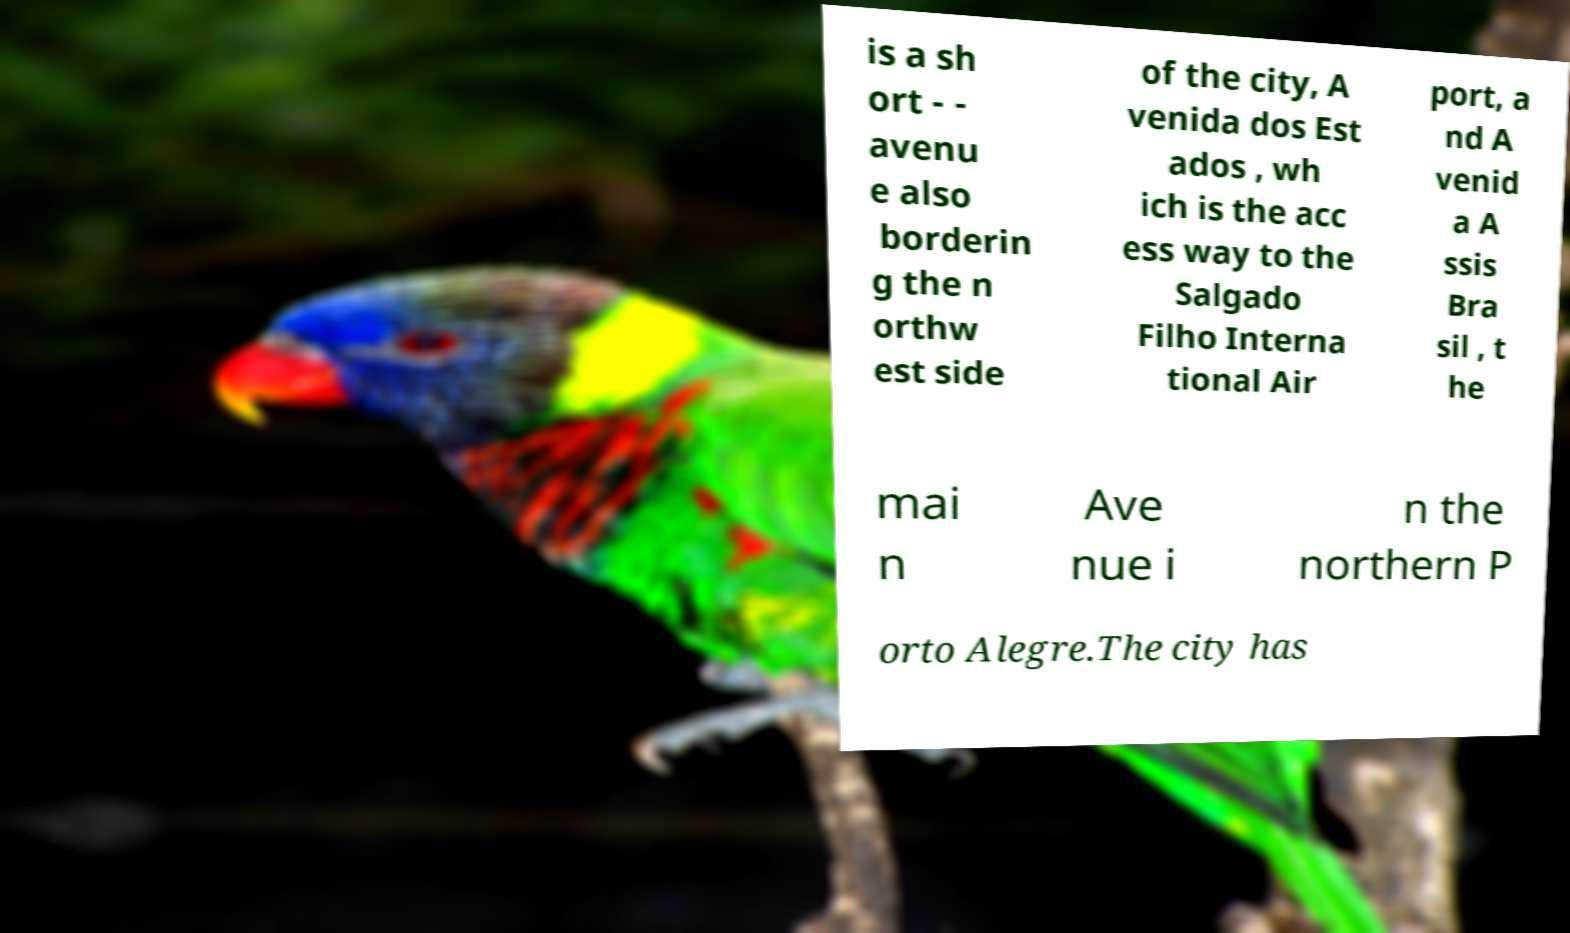Please read and relay the text visible in this image. What does it say? is a sh ort - - avenu e also borderin g the n orthw est side of the city, A venida dos Est ados , wh ich is the acc ess way to the Salgado Filho Interna tional Air port, a nd A venid a A ssis Bra sil , t he mai n Ave nue i n the northern P orto Alegre.The city has 